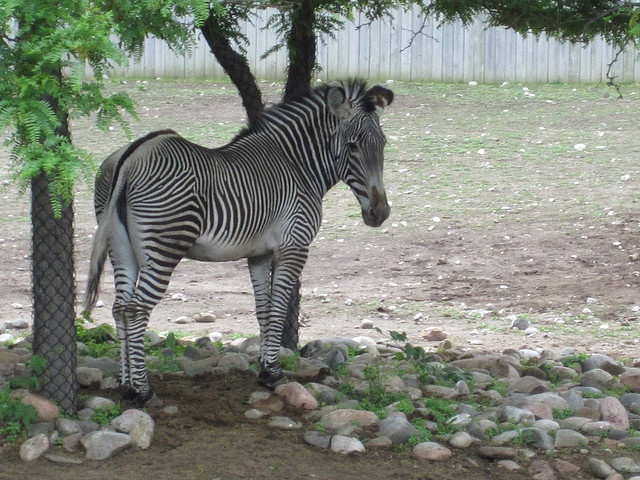Describe the objects in this image and their specific colors. I can see a zebra in lightgreen, gray, black, and darkgray tones in this image. 